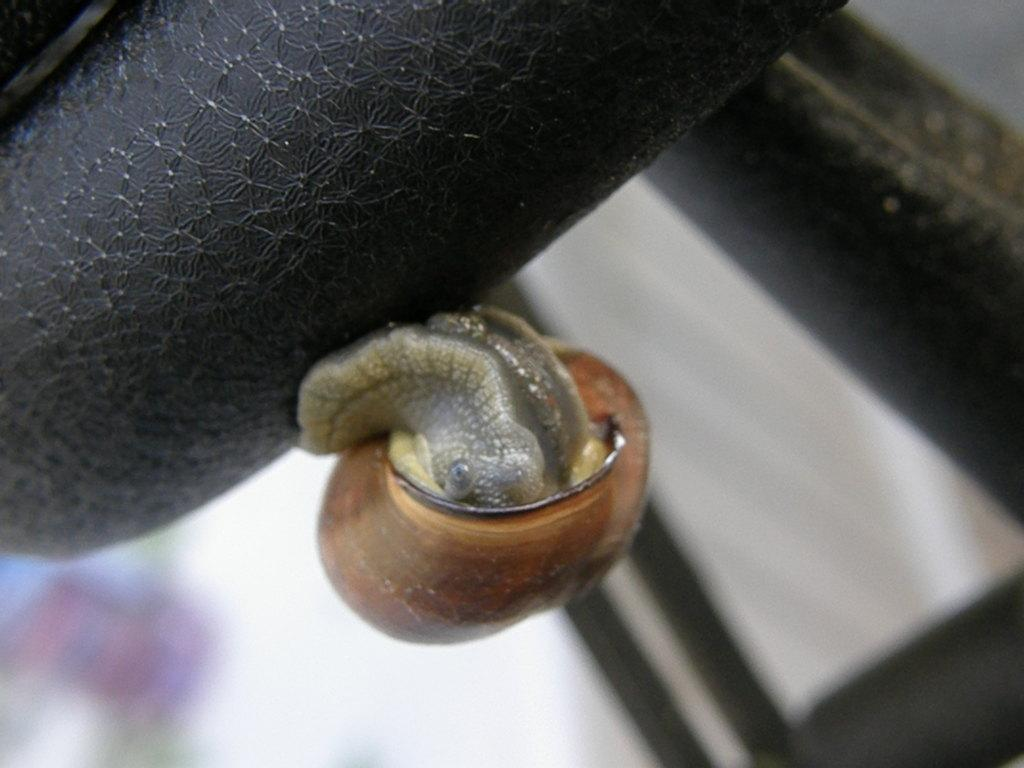What type of animal is present in the image? There is a snail in the image. What is the snail resting on? The snail is on a black object. How many firemen are present in the image? There are no firemen present in the image; it features a snail on a black object. 